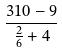Convert formula to latex. <formula><loc_0><loc_0><loc_500><loc_500>\frac { 3 1 0 - 9 } { \frac { 2 } { 6 } + 4 }</formula> 